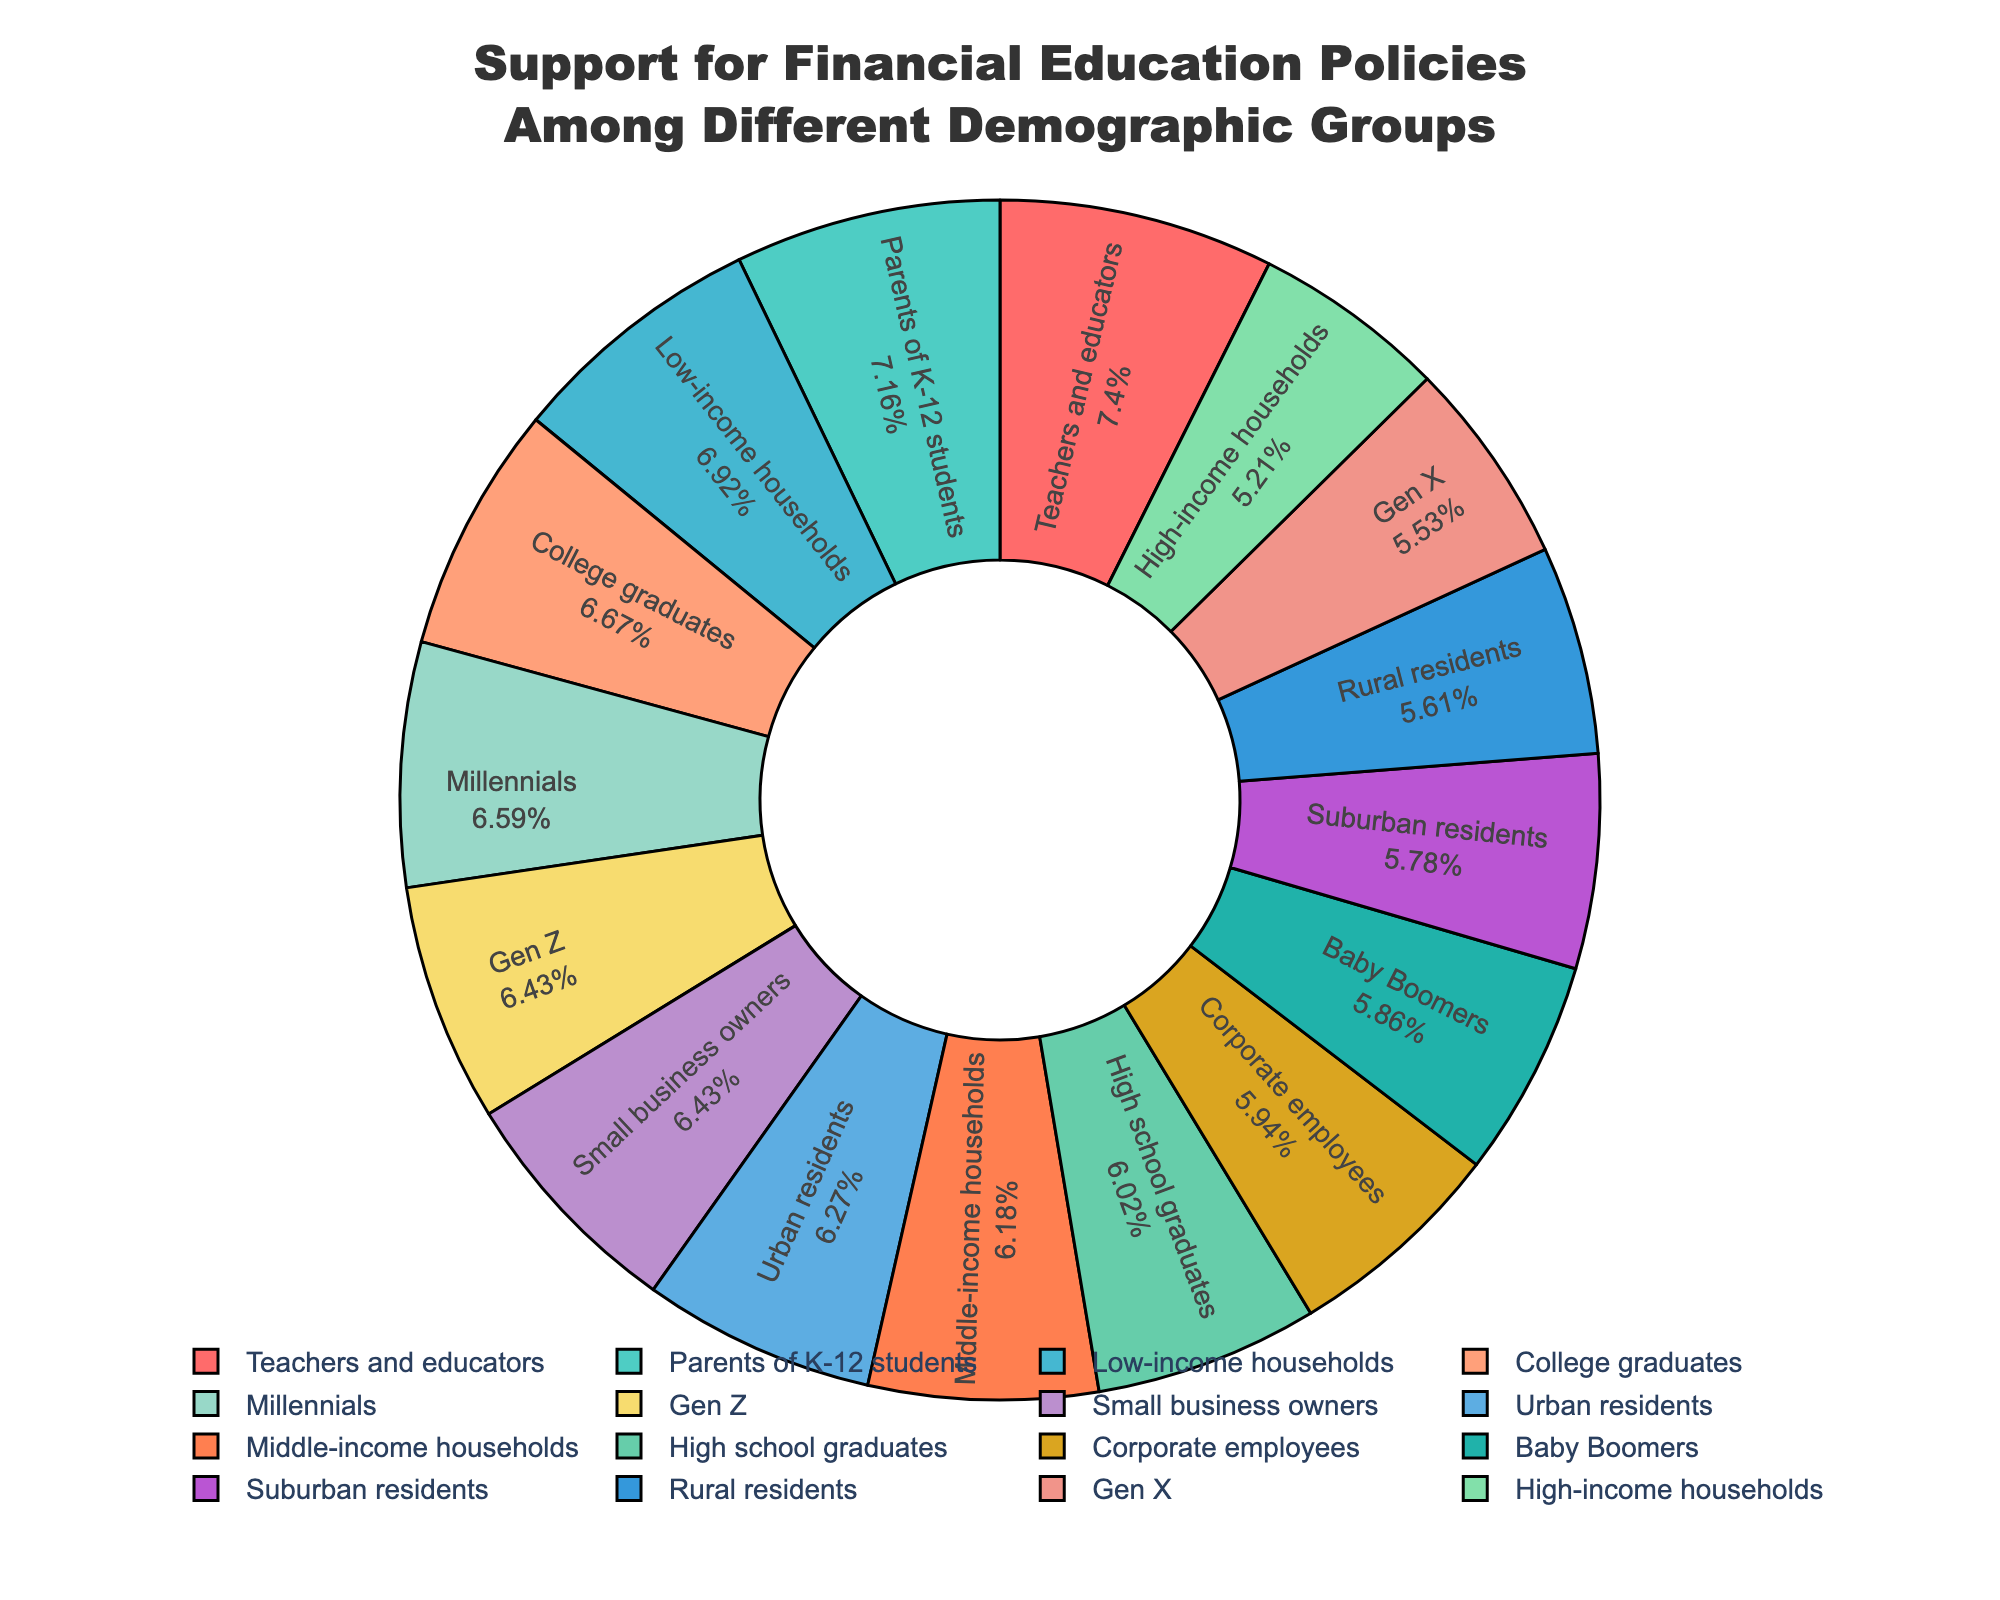What is the demographic group with the highest support percentage for financial education policies? The pie chart shows different demographic groups and their support percentages. By identifying the group with the largest slice or the highest percentage label, we find the highest support percentage.
Answer: Teachers and educators Which demographic group has the lowest support percentage, and what is that percentage? By examining the pie chart, we can identify the group with the smallest slice or the lowest percentage label to determine the lowest support percentage.
Answer: High-income households (64%) How does the support percentage for financial education policies among Gen Z compare to Millennials? Locate the slices for Gen Z and Millennials in the pie chart and compare their percentages. Gen Z is 79%, and Millennials are 81%. Hence, we observe that Millennials have higher support.
Answer: Millennials have higher support Which group has higher support for financial education policies, rural residents or suburban residents, and by how much? Determine the support percentages for rural residents (69%) and suburban residents (71%). Subtract the smaller percentage from the larger one to find the difference.
Answer: Suburban residents have 2% higher support How does the support percentage for parents of K-12 students compare to small business owners? Locate the support percentages for parents of K-12 students (88%) and small business owners (79%). Compare them to find which is higher and by how much.
Answer: Parents of K-12 students have 9% higher support Do urban residents have greater or lesser support than corporate employees, and by what percentage? Locate the support percentages for urban residents (77%) and corporate employees (73%). Compare them to determine if one is greater and by how much.
Answer: Urban residents have 4% greater support What percentage of the demographic groups listed have a support percentage of 80% or higher? Count the number of demographic groups with support percentages at or above 80%. These groups are Millennials (81%), Gen Z (79%), low-income households (85%), college graduates (82%), parents of K-12 students (88%), and teachers/educators (91%). Since Gen Z is close but not at 80%, we exclude them. Five groups meet this criteria.
Answer: 5 groups 